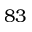Convert formula to latex. <formula><loc_0><loc_0><loc_500><loc_500>8 3</formula> 